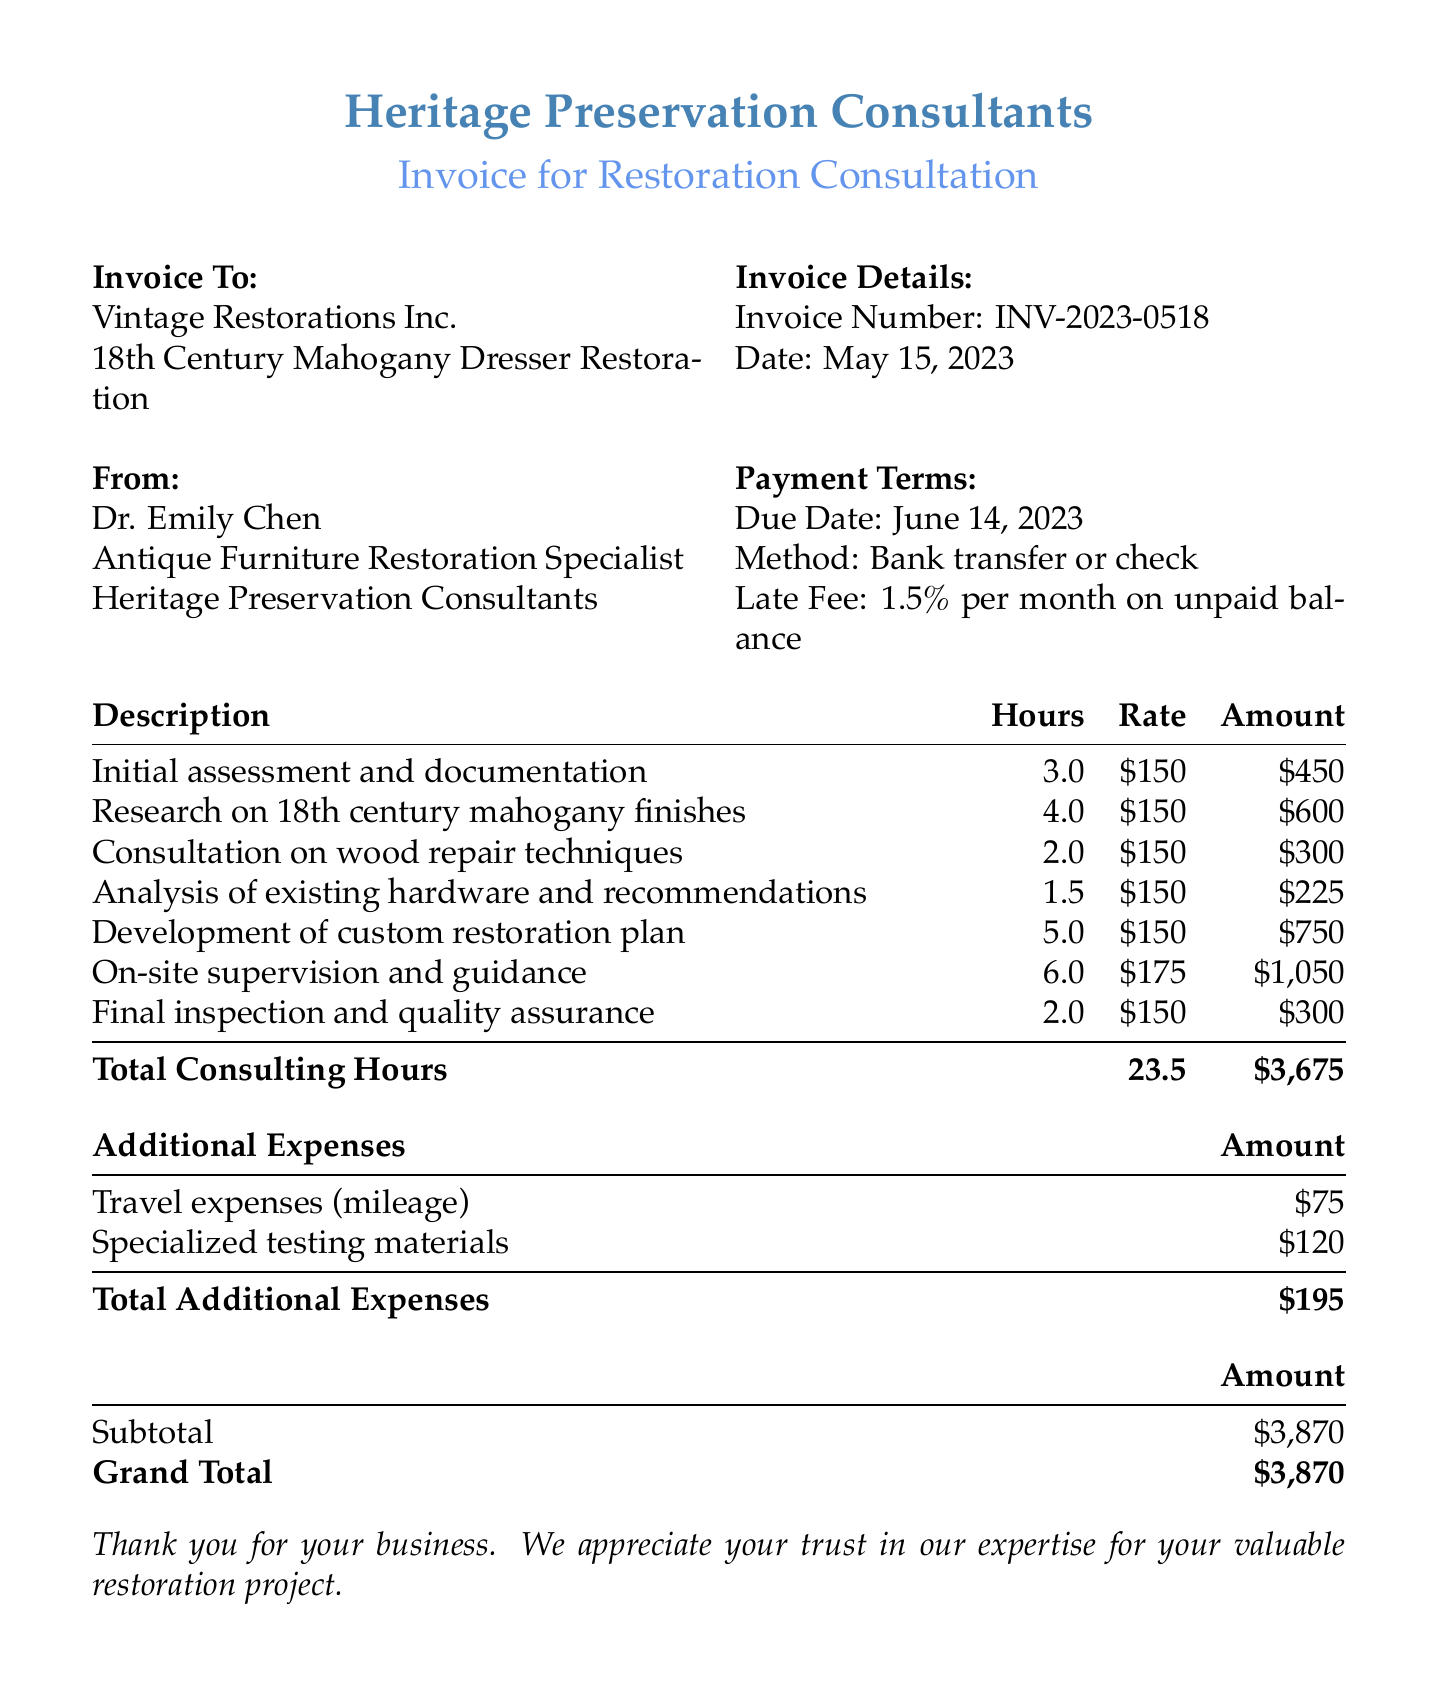What is the client name? The client name is listed in the document under the "Invoice To" section.
Answer: Vintage Restorations Inc Who is the consultant? The consultant's name is prominently displayed at the top of the document.
Answer: Dr. Emily Chen What is the total number of consulting hours? The total consulting hours are calculated and listed in the itemized fees section.
Answer: 23.5 What is the grand total amount due? The grand total is found at the bottom of the invoice under the summary.
Answer: $3,870 What is the due date for payment? The due date is stated in the "Payment Terms" section of the document.
Answer: June 14, 2023 How much was charged for on-site supervision and guidance? This fee is detailed in the itemized fees table and includes hours, rate, and the subtotal.
Answer: $1,050 What was the rate per hour for most of the consulting services? The document details the hourly rates in the itemized fees section.
Answer: $150 What is the amount for travel expenses? The travel expenses are listed under the "Additional Expenses" section.
Answer: $75 What is the late fee percentage on unpaid balance? The late fee is stated explicitly in the "Payment Terms" section of the invoice.
Answer: 1.5% per month 